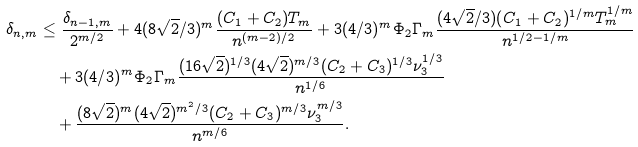<formula> <loc_0><loc_0><loc_500><loc_500>\delta _ { n , m } & \leq \frac { \delta _ { n - 1 , m } } { 2 ^ { m / 2 } } + 4 ( 8 \sqrt { 2 } / 3 ) ^ { m } \frac { ( C _ { 1 } + C _ { 2 } ) T _ { m } } { n ^ { ( m - 2 ) / 2 } } + 3 ( 4 / 3 ) ^ { m } \Phi _ { 2 } \Gamma _ { m } \frac { ( 4 \sqrt { 2 } / 3 ) ( C _ { 1 } + C _ { 2 } ) ^ { 1 / m } T ^ { 1 / m } _ { m } } { n ^ { 1 / 2 - 1 / m } } \\ & \quad + 3 ( 4 / 3 ) ^ { m } \Phi _ { 2 } \Gamma _ { m } \frac { ( 1 6 \sqrt { 2 } ) ^ { 1 / 3 } ( 4 \sqrt { 2 } ) ^ { m / 3 } ( C _ { 2 } + C _ { 3 } ) ^ { 1 / 3 } \nu _ { 3 } ^ { 1 / 3 } } { n ^ { 1 / 6 } } \\ & \quad + \frac { ( 8 \sqrt { 2 } ) ^ { m } ( 4 \sqrt { 2 } ) ^ { m ^ { 2 } / 3 } ( C _ { 2 } + C _ { 3 } ) ^ { m / 3 } \nu _ { 3 } ^ { m / 3 } } { n ^ { m / 6 } } .</formula> 